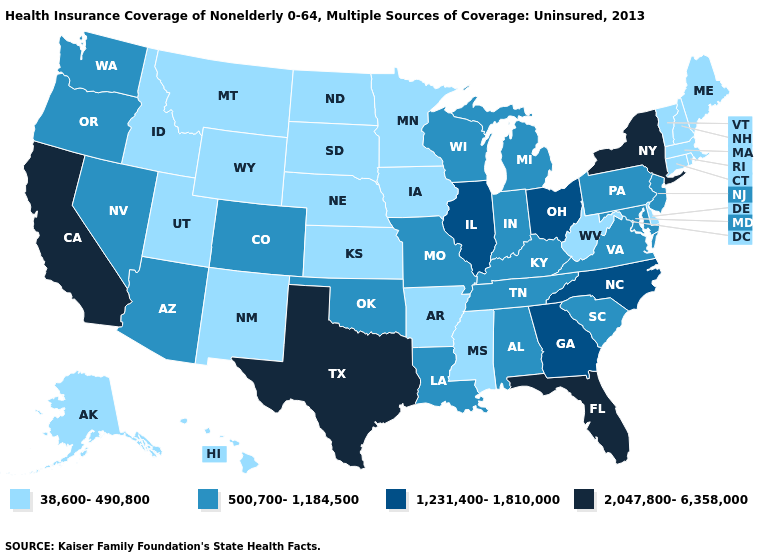Name the states that have a value in the range 500,700-1,184,500?
Short answer required. Alabama, Arizona, Colorado, Indiana, Kentucky, Louisiana, Maryland, Michigan, Missouri, Nevada, New Jersey, Oklahoma, Oregon, Pennsylvania, South Carolina, Tennessee, Virginia, Washington, Wisconsin. Among the states that border Oklahoma , does Texas have the highest value?
Short answer required. Yes. What is the lowest value in the Northeast?
Concise answer only. 38,600-490,800. Does the first symbol in the legend represent the smallest category?
Concise answer only. Yes. Does New York have a higher value than California?
Give a very brief answer. No. Name the states that have a value in the range 1,231,400-1,810,000?
Answer briefly. Georgia, Illinois, North Carolina, Ohio. Is the legend a continuous bar?
Keep it brief. No. Among the states that border Arkansas , which have the lowest value?
Keep it brief. Mississippi. Name the states that have a value in the range 500,700-1,184,500?
Keep it brief. Alabama, Arizona, Colorado, Indiana, Kentucky, Louisiana, Maryland, Michigan, Missouri, Nevada, New Jersey, Oklahoma, Oregon, Pennsylvania, South Carolina, Tennessee, Virginia, Washington, Wisconsin. Name the states that have a value in the range 2,047,800-6,358,000?
Short answer required. California, Florida, New York, Texas. Does Maryland have a lower value than North Carolina?
Keep it brief. Yes. Does Virginia have the lowest value in the USA?
Quick response, please. No. What is the value of Nebraska?
Give a very brief answer. 38,600-490,800. What is the value of Mississippi?
Answer briefly. 38,600-490,800. Among the states that border Virginia , does Tennessee have the highest value?
Give a very brief answer. No. 